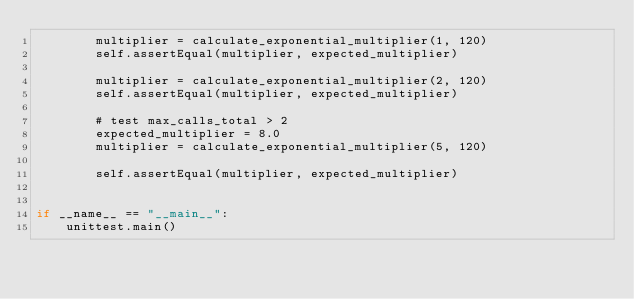<code> <loc_0><loc_0><loc_500><loc_500><_Python_>        multiplier = calculate_exponential_multiplier(1, 120)
        self.assertEqual(multiplier, expected_multiplier)

        multiplier = calculate_exponential_multiplier(2, 120)
        self.assertEqual(multiplier, expected_multiplier)

        # test max_calls_total > 2
        expected_multiplier = 8.0
        multiplier = calculate_exponential_multiplier(5, 120)

        self.assertEqual(multiplier, expected_multiplier)


if __name__ == "__main__":
    unittest.main()
</code> 